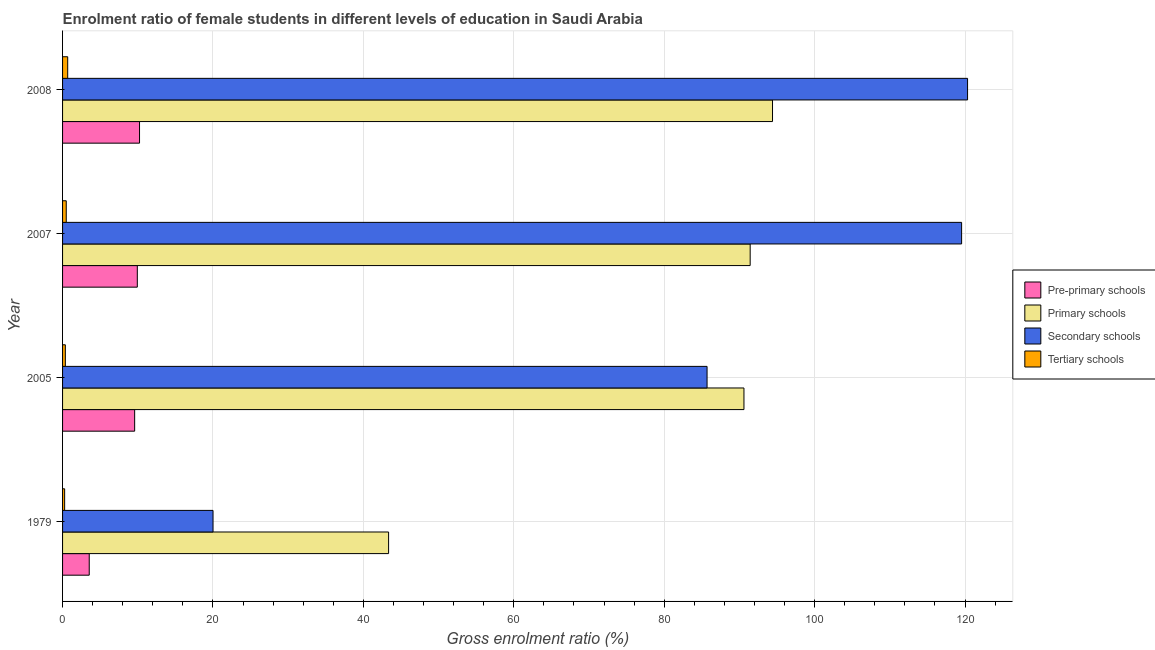Are the number of bars on each tick of the Y-axis equal?
Keep it short and to the point. Yes. How many bars are there on the 4th tick from the top?
Provide a short and direct response. 4. What is the label of the 4th group of bars from the top?
Provide a short and direct response. 1979. What is the gross enrolment ratio(male) in primary schools in 2005?
Make the answer very short. 90.6. Across all years, what is the maximum gross enrolment ratio(male) in secondary schools?
Provide a succinct answer. 120.33. Across all years, what is the minimum gross enrolment ratio(male) in tertiary schools?
Give a very brief answer. 0.28. In which year was the gross enrolment ratio(male) in pre-primary schools maximum?
Give a very brief answer. 2008. In which year was the gross enrolment ratio(male) in secondary schools minimum?
Your answer should be very brief. 1979. What is the total gross enrolment ratio(male) in pre-primary schools in the graph?
Provide a short and direct response. 33.31. What is the difference between the gross enrolment ratio(male) in secondary schools in 2005 and that in 2008?
Provide a short and direct response. -34.64. What is the difference between the gross enrolment ratio(male) in tertiary schools in 2005 and the gross enrolment ratio(male) in pre-primary schools in 2008?
Your answer should be compact. -9.86. What is the average gross enrolment ratio(male) in secondary schools per year?
Your answer should be compact. 86.39. In the year 2005, what is the difference between the gross enrolment ratio(male) in pre-primary schools and gross enrolment ratio(male) in secondary schools?
Offer a terse response. -76.11. What is the ratio of the gross enrolment ratio(male) in primary schools in 1979 to that in 2008?
Provide a short and direct response. 0.46. What is the difference between the highest and the second highest gross enrolment ratio(male) in tertiary schools?
Provide a short and direct response. 0.19. What is the difference between the highest and the lowest gross enrolment ratio(male) in pre-primary schools?
Make the answer very short. 6.69. In how many years, is the gross enrolment ratio(male) in primary schools greater than the average gross enrolment ratio(male) in primary schools taken over all years?
Make the answer very short. 3. What does the 3rd bar from the top in 1979 represents?
Your answer should be very brief. Primary schools. What does the 4th bar from the bottom in 2005 represents?
Your answer should be compact. Tertiary schools. How many bars are there?
Provide a short and direct response. 16. Are all the bars in the graph horizontal?
Provide a succinct answer. Yes. How many years are there in the graph?
Ensure brevity in your answer.  4. What is the difference between two consecutive major ticks on the X-axis?
Offer a very short reply. 20. Are the values on the major ticks of X-axis written in scientific E-notation?
Make the answer very short. No. Does the graph contain any zero values?
Your answer should be compact. No. How many legend labels are there?
Give a very brief answer. 4. How are the legend labels stacked?
Ensure brevity in your answer.  Vertical. What is the title of the graph?
Offer a terse response. Enrolment ratio of female students in different levels of education in Saudi Arabia. What is the label or title of the X-axis?
Make the answer very short. Gross enrolment ratio (%). What is the label or title of the Y-axis?
Provide a succinct answer. Year. What is the Gross enrolment ratio (%) in Pre-primary schools in 1979?
Provide a short and direct response. 3.55. What is the Gross enrolment ratio (%) of Primary schools in 1979?
Keep it short and to the point. 43.35. What is the Gross enrolment ratio (%) in Secondary schools in 1979?
Offer a terse response. 20.01. What is the Gross enrolment ratio (%) in Tertiary schools in 1979?
Your answer should be compact. 0.28. What is the Gross enrolment ratio (%) of Pre-primary schools in 2005?
Ensure brevity in your answer.  9.59. What is the Gross enrolment ratio (%) of Primary schools in 2005?
Make the answer very short. 90.6. What is the Gross enrolment ratio (%) in Secondary schools in 2005?
Offer a terse response. 85.7. What is the Gross enrolment ratio (%) in Tertiary schools in 2005?
Ensure brevity in your answer.  0.37. What is the Gross enrolment ratio (%) of Pre-primary schools in 2007?
Ensure brevity in your answer.  9.94. What is the Gross enrolment ratio (%) in Primary schools in 2007?
Your answer should be very brief. 91.43. What is the Gross enrolment ratio (%) in Secondary schools in 2007?
Give a very brief answer. 119.54. What is the Gross enrolment ratio (%) of Tertiary schools in 2007?
Offer a very short reply. 0.49. What is the Gross enrolment ratio (%) in Pre-primary schools in 2008?
Your answer should be compact. 10.23. What is the Gross enrolment ratio (%) in Primary schools in 2008?
Give a very brief answer. 94.4. What is the Gross enrolment ratio (%) in Secondary schools in 2008?
Your response must be concise. 120.33. What is the Gross enrolment ratio (%) of Tertiary schools in 2008?
Your answer should be very brief. 0.68. Across all years, what is the maximum Gross enrolment ratio (%) in Pre-primary schools?
Your answer should be very brief. 10.23. Across all years, what is the maximum Gross enrolment ratio (%) of Primary schools?
Make the answer very short. 94.4. Across all years, what is the maximum Gross enrolment ratio (%) in Secondary schools?
Your response must be concise. 120.33. Across all years, what is the maximum Gross enrolment ratio (%) of Tertiary schools?
Offer a very short reply. 0.68. Across all years, what is the minimum Gross enrolment ratio (%) of Pre-primary schools?
Offer a terse response. 3.55. Across all years, what is the minimum Gross enrolment ratio (%) in Primary schools?
Your response must be concise. 43.35. Across all years, what is the minimum Gross enrolment ratio (%) in Secondary schools?
Offer a very short reply. 20.01. Across all years, what is the minimum Gross enrolment ratio (%) in Tertiary schools?
Offer a very short reply. 0.28. What is the total Gross enrolment ratio (%) of Pre-primary schools in the graph?
Make the answer very short. 33.31. What is the total Gross enrolment ratio (%) in Primary schools in the graph?
Give a very brief answer. 319.78. What is the total Gross enrolment ratio (%) of Secondary schools in the graph?
Ensure brevity in your answer.  345.57. What is the total Gross enrolment ratio (%) of Tertiary schools in the graph?
Your response must be concise. 1.82. What is the difference between the Gross enrolment ratio (%) in Pre-primary schools in 1979 and that in 2005?
Make the answer very short. -6.04. What is the difference between the Gross enrolment ratio (%) in Primary schools in 1979 and that in 2005?
Provide a short and direct response. -47.25. What is the difference between the Gross enrolment ratio (%) in Secondary schools in 1979 and that in 2005?
Your answer should be very brief. -65.69. What is the difference between the Gross enrolment ratio (%) of Tertiary schools in 1979 and that in 2005?
Keep it short and to the point. -0.09. What is the difference between the Gross enrolment ratio (%) in Pre-primary schools in 1979 and that in 2007?
Your response must be concise. -6.39. What is the difference between the Gross enrolment ratio (%) in Primary schools in 1979 and that in 2007?
Offer a terse response. -48.08. What is the difference between the Gross enrolment ratio (%) of Secondary schools in 1979 and that in 2007?
Provide a succinct answer. -99.53. What is the difference between the Gross enrolment ratio (%) in Tertiary schools in 1979 and that in 2007?
Make the answer very short. -0.21. What is the difference between the Gross enrolment ratio (%) of Pre-primary schools in 1979 and that in 2008?
Offer a very short reply. -6.69. What is the difference between the Gross enrolment ratio (%) of Primary schools in 1979 and that in 2008?
Offer a very short reply. -51.05. What is the difference between the Gross enrolment ratio (%) of Secondary schools in 1979 and that in 2008?
Provide a succinct answer. -100.33. What is the difference between the Gross enrolment ratio (%) in Tertiary schools in 1979 and that in 2008?
Make the answer very short. -0.41. What is the difference between the Gross enrolment ratio (%) of Pre-primary schools in 2005 and that in 2007?
Make the answer very short. -0.35. What is the difference between the Gross enrolment ratio (%) in Primary schools in 2005 and that in 2007?
Offer a terse response. -0.83. What is the difference between the Gross enrolment ratio (%) in Secondary schools in 2005 and that in 2007?
Give a very brief answer. -33.85. What is the difference between the Gross enrolment ratio (%) in Tertiary schools in 2005 and that in 2007?
Make the answer very short. -0.12. What is the difference between the Gross enrolment ratio (%) in Pre-primary schools in 2005 and that in 2008?
Your answer should be compact. -0.65. What is the difference between the Gross enrolment ratio (%) of Primary schools in 2005 and that in 2008?
Your answer should be very brief. -3.8. What is the difference between the Gross enrolment ratio (%) of Secondary schools in 2005 and that in 2008?
Offer a terse response. -34.64. What is the difference between the Gross enrolment ratio (%) in Tertiary schools in 2005 and that in 2008?
Give a very brief answer. -0.31. What is the difference between the Gross enrolment ratio (%) of Pre-primary schools in 2007 and that in 2008?
Your response must be concise. -0.29. What is the difference between the Gross enrolment ratio (%) in Primary schools in 2007 and that in 2008?
Offer a very short reply. -2.97. What is the difference between the Gross enrolment ratio (%) of Secondary schools in 2007 and that in 2008?
Your answer should be compact. -0.79. What is the difference between the Gross enrolment ratio (%) in Tertiary schools in 2007 and that in 2008?
Ensure brevity in your answer.  -0.19. What is the difference between the Gross enrolment ratio (%) in Pre-primary schools in 1979 and the Gross enrolment ratio (%) in Primary schools in 2005?
Provide a succinct answer. -87.05. What is the difference between the Gross enrolment ratio (%) in Pre-primary schools in 1979 and the Gross enrolment ratio (%) in Secondary schools in 2005?
Provide a succinct answer. -82.15. What is the difference between the Gross enrolment ratio (%) in Pre-primary schools in 1979 and the Gross enrolment ratio (%) in Tertiary schools in 2005?
Your response must be concise. 3.18. What is the difference between the Gross enrolment ratio (%) of Primary schools in 1979 and the Gross enrolment ratio (%) of Secondary schools in 2005?
Offer a terse response. -42.34. What is the difference between the Gross enrolment ratio (%) of Primary schools in 1979 and the Gross enrolment ratio (%) of Tertiary schools in 2005?
Your response must be concise. 42.98. What is the difference between the Gross enrolment ratio (%) of Secondary schools in 1979 and the Gross enrolment ratio (%) of Tertiary schools in 2005?
Offer a very short reply. 19.64. What is the difference between the Gross enrolment ratio (%) of Pre-primary schools in 1979 and the Gross enrolment ratio (%) of Primary schools in 2007?
Your response must be concise. -87.88. What is the difference between the Gross enrolment ratio (%) of Pre-primary schools in 1979 and the Gross enrolment ratio (%) of Secondary schools in 2007?
Keep it short and to the point. -115.99. What is the difference between the Gross enrolment ratio (%) in Pre-primary schools in 1979 and the Gross enrolment ratio (%) in Tertiary schools in 2007?
Give a very brief answer. 3.06. What is the difference between the Gross enrolment ratio (%) of Primary schools in 1979 and the Gross enrolment ratio (%) of Secondary schools in 2007?
Your answer should be compact. -76.19. What is the difference between the Gross enrolment ratio (%) in Primary schools in 1979 and the Gross enrolment ratio (%) in Tertiary schools in 2007?
Your answer should be compact. 42.86. What is the difference between the Gross enrolment ratio (%) of Secondary schools in 1979 and the Gross enrolment ratio (%) of Tertiary schools in 2007?
Provide a succinct answer. 19.52. What is the difference between the Gross enrolment ratio (%) in Pre-primary schools in 1979 and the Gross enrolment ratio (%) in Primary schools in 2008?
Ensure brevity in your answer.  -90.85. What is the difference between the Gross enrolment ratio (%) of Pre-primary schools in 1979 and the Gross enrolment ratio (%) of Secondary schools in 2008?
Ensure brevity in your answer.  -116.78. What is the difference between the Gross enrolment ratio (%) of Pre-primary schools in 1979 and the Gross enrolment ratio (%) of Tertiary schools in 2008?
Give a very brief answer. 2.86. What is the difference between the Gross enrolment ratio (%) in Primary schools in 1979 and the Gross enrolment ratio (%) in Secondary schools in 2008?
Give a very brief answer. -76.98. What is the difference between the Gross enrolment ratio (%) of Primary schools in 1979 and the Gross enrolment ratio (%) of Tertiary schools in 2008?
Your answer should be compact. 42.67. What is the difference between the Gross enrolment ratio (%) of Secondary schools in 1979 and the Gross enrolment ratio (%) of Tertiary schools in 2008?
Give a very brief answer. 19.32. What is the difference between the Gross enrolment ratio (%) of Pre-primary schools in 2005 and the Gross enrolment ratio (%) of Primary schools in 2007?
Offer a very short reply. -81.84. What is the difference between the Gross enrolment ratio (%) of Pre-primary schools in 2005 and the Gross enrolment ratio (%) of Secondary schools in 2007?
Offer a very short reply. -109.95. What is the difference between the Gross enrolment ratio (%) of Pre-primary schools in 2005 and the Gross enrolment ratio (%) of Tertiary schools in 2007?
Your answer should be very brief. 9.1. What is the difference between the Gross enrolment ratio (%) of Primary schools in 2005 and the Gross enrolment ratio (%) of Secondary schools in 2007?
Your response must be concise. -28.94. What is the difference between the Gross enrolment ratio (%) in Primary schools in 2005 and the Gross enrolment ratio (%) in Tertiary schools in 2007?
Your answer should be compact. 90.11. What is the difference between the Gross enrolment ratio (%) of Secondary schools in 2005 and the Gross enrolment ratio (%) of Tertiary schools in 2007?
Keep it short and to the point. 85.21. What is the difference between the Gross enrolment ratio (%) in Pre-primary schools in 2005 and the Gross enrolment ratio (%) in Primary schools in 2008?
Your response must be concise. -84.81. What is the difference between the Gross enrolment ratio (%) in Pre-primary schools in 2005 and the Gross enrolment ratio (%) in Secondary schools in 2008?
Give a very brief answer. -110.75. What is the difference between the Gross enrolment ratio (%) of Pre-primary schools in 2005 and the Gross enrolment ratio (%) of Tertiary schools in 2008?
Make the answer very short. 8.9. What is the difference between the Gross enrolment ratio (%) of Primary schools in 2005 and the Gross enrolment ratio (%) of Secondary schools in 2008?
Keep it short and to the point. -29.73. What is the difference between the Gross enrolment ratio (%) of Primary schools in 2005 and the Gross enrolment ratio (%) of Tertiary schools in 2008?
Offer a terse response. 89.92. What is the difference between the Gross enrolment ratio (%) in Secondary schools in 2005 and the Gross enrolment ratio (%) in Tertiary schools in 2008?
Offer a terse response. 85.01. What is the difference between the Gross enrolment ratio (%) in Pre-primary schools in 2007 and the Gross enrolment ratio (%) in Primary schools in 2008?
Your response must be concise. -84.46. What is the difference between the Gross enrolment ratio (%) of Pre-primary schools in 2007 and the Gross enrolment ratio (%) of Secondary schools in 2008?
Offer a very short reply. -110.39. What is the difference between the Gross enrolment ratio (%) of Pre-primary schools in 2007 and the Gross enrolment ratio (%) of Tertiary schools in 2008?
Ensure brevity in your answer.  9.25. What is the difference between the Gross enrolment ratio (%) of Primary schools in 2007 and the Gross enrolment ratio (%) of Secondary schools in 2008?
Offer a terse response. -28.9. What is the difference between the Gross enrolment ratio (%) of Primary schools in 2007 and the Gross enrolment ratio (%) of Tertiary schools in 2008?
Offer a very short reply. 90.74. What is the difference between the Gross enrolment ratio (%) in Secondary schools in 2007 and the Gross enrolment ratio (%) in Tertiary schools in 2008?
Your response must be concise. 118.86. What is the average Gross enrolment ratio (%) in Pre-primary schools per year?
Keep it short and to the point. 8.33. What is the average Gross enrolment ratio (%) of Primary schools per year?
Offer a terse response. 79.94. What is the average Gross enrolment ratio (%) in Secondary schools per year?
Offer a very short reply. 86.39. What is the average Gross enrolment ratio (%) in Tertiary schools per year?
Keep it short and to the point. 0.46. In the year 1979, what is the difference between the Gross enrolment ratio (%) in Pre-primary schools and Gross enrolment ratio (%) in Primary schools?
Ensure brevity in your answer.  -39.8. In the year 1979, what is the difference between the Gross enrolment ratio (%) in Pre-primary schools and Gross enrolment ratio (%) in Secondary schools?
Provide a short and direct response. -16.46. In the year 1979, what is the difference between the Gross enrolment ratio (%) in Pre-primary schools and Gross enrolment ratio (%) in Tertiary schools?
Give a very brief answer. 3.27. In the year 1979, what is the difference between the Gross enrolment ratio (%) in Primary schools and Gross enrolment ratio (%) in Secondary schools?
Make the answer very short. 23.34. In the year 1979, what is the difference between the Gross enrolment ratio (%) of Primary schools and Gross enrolment ratio (%) of Tertiary schools?
Your answer should be very brief. 43.07. In the year 1979, what is the difference between the Gross enrolment ratio (%) of Secondary schools and Gross enrolment ratio (%) of Tertiary schools?
Ensure brevity in your answer.  19.73. In the year 2005, what is the difference between the Gross enrolment ratio (%) in Pre-primary schools and Gross enrolment ratio (%) in Primary schools?
Give a very brief answer. -81.01. In the year 2005, what is the difference between the Gross enrolment ratio (%) in Pre-primary schools and Gross enrolment ratio (%) in Secondary schools?
Keep it short and to the point. -76.11. In the year 2005, what is the difference between the Gross enrolment ratio (%) in Pre-primary schools and Gross enrolment ratio (%) in Tertiary schools?
Provide a succinct answer. 9.22. In the year 2005, what is the difference between the Gross enrolment ratio (%) in Primary schools and Gross enrolment ratio (%) in Secondary schools?
Provide a succinct answer. 4.91. In the year 2005, what is the difference between the Gross enrolment ratio (%) in Primary schools and Gross enrolment ratio (%) in Tertiary schools?
Offer a very short reply. 90.23. In the year 2005, what is the difference between the Gross enrolment ratio (%) in Secondary schools and Gross enrolment ratio (%) in Tertiary schools?
Provide a succinct answer. 85.33. In the year 2007, what is the difference between the Gross enrolment ratio (%) in Pre-primary schools and Gross enrolment ratio (%) in Primary schools?
Your response must be concise. -81.49. In the year 2007, what is the difference between the Gross enrolment ratio (%) in Pre-primary schools and Gross enrolment ratio (%) in Secondary schools?
Make the answer very short. -109.6. In the year 2007, what is the difference between the Gross enrolment ratio (%) of Pre-primary schools and Gross enrolment ratio (%) of Tertiary schools?
Offer a very short reply. 9.45. In the year 2007, what is the difference between the Gross enrolment ratio (%) in Primary schools and Gross enrolment ratio (%) in Secondary schools?
Your answer should be compact. -28.11. In the year 2007, what is the difference between the Gross enrolment ratio (%) of Primary schools and Gross enrolment ratio (%) of Tertiary schools?
Make the answer very short. 90.94. In the year 2007, what is the difference between the Gross enrolment ratio (%) in Secondary schools and Gross enrolment ratio (%) in Tertiary schools?
Provide a succinct answer. 119.05. In the year 2008, what is the difference between the Gross enrolment ratio (%) of Pre-primary schools and Gross enrolment ratio (%) of Primary schools?
Offer a terse response. -84.16. In the year 2008, what is the difference between the Gross enrolment ratio (%) in Pre-primary schools and Gross enrolment ratio (%) in Secondary schools?
Give a very brief answer. -110.1. In the year 2008, what is the difference between the Gross enrolment ratio (%) of Pre-primary schools and Gross enrolment ratio (%) of Tertiary schools?
Your answer should be very brief. 9.55. In the year 2008, what is the difference between the Gross enrolment ratio (%) of Primary schools and Gross enrolment ratio (%) of Secondary schools?
Your answer should be compact. -25.93. In the year 2008, what is the difference between the Gross enrolment ratio (%) in Primary schools and Gross enrolment ratio (%) in Tertiary schools?
Offer a terse response. 93.71. In the year 2008, what is the difference between the Gross enrolment ratio (%) of Secondary schools and Gross enrolment ratio (%) of Tertiary schools?
Your answer should be very brief. 119.65. What is the ratio of the Gross enrolment ratio (%) in Pre-primary schools in 1979 to that in 2005?
Make the answer very short. 0.37. What is the ratio of the Gross enrolment ratio (%) of Primary schools in 1979 to that in 2005?
Offer a terse response. 0.48. What is the ratio of the Gross enrolment ratio (%) in Secondary schools in 1979 to that in 2005?
Offer a terse response. 0.23. What is the ratio of the Gross enrolment ratio (%) in Tertiary schools in 1979 to that in 2005?
Offer a very short reply. 0.75. What is the ratio of the Gross enrolment ratio (%) of Pre-primary schools in 1979 to that in 2007?
Give a very brief answer. 0.36. What is the ratio of the Gross enrolment ratio (%) in Primary schools in 1979 to that in 2007?
Give a very brief answer. 0.47. What is the ratio of the Gross enrolment ratio (%) in Secondary schools in 1979 to that in 2007?
Your response must be concise. 0.17. What is the ratio of the Gross enrolment ratio (%) of Tertiary schools in 1979 to that in 2007?
Offer a very short reply. 0.56. What is the ratio of the Gross enrolment ratio (%) of Pre-primary schools in 1979 to that in 2008?
Provide a short and direct response. 0.35. What is the ratio of the Gross enrolment ratio (%) of Primary schools in 1979 to that in 2008?
Give a very brief answer. 0.46. What is the ratio of the Gross enrolment ratio (%) in Secondary schools in 1979 to that in 2008?
Make the answer very short. 0.17. What is the ratio of the Gross enrolment ratio (%) in Tertiary schools in 1979 to that in 2008?
Ensure brevity in your answer.  0.4. What is the ratio of the Gross enrolment ratio (%) in Pre-primary schools in 2005 to that in 2007?
Provide a short and direct response. 0.96. What is the ratio of the Gross enrolment ratio (%) in Primary schools in 2005 to that in 2007?
Ensure brevity in your answer.  0.99. What is the ratio of the Gross enrolment ratio (%) in Secondary schools in 2005 to that in 2007?
Offer a terse response. 0.72. What is the ratio of the Gross enrolment ratio (%) of Tertiary schools in 2005 to that in 2007?
Your answer should be compact. 0.76. What is the ratio of the Gross enrolment ratio (%) in Pre-primary schools in 2005 to that in 2008?
Your answer should be compact. 0.94. What is the ratio of the Gross enrolment ratio (%) in Primary schools in 2005 to that in 2008?
Your answer should be very brief. 0.96. What is the ratio of the Gross enrolment ratio (%) in Secondary schools in 2005 to that in 2008?
Offer a terse response. 0.71. What is the ratio of the Gross enrolment ratio (%) in Tertiary schools in 2005 to that in 2008?
Your answer should be very brief. 0.54. What is the ratio of the Gross enrolment ratio (%) of Pre-primary schools in 2007 to that in 2008?
Offer a very short reply. 0.97. What is the ratio of the Gross enrolment ratio (%) of Primary schools in 2007 to that in 2008?
Offer a terse response. 0.97. What is the ratio of the Gross enrolment ratio (%) of Secondary schools in 2007 to that in 2008?
Make the answer very short. 0.99. What is the ratio of the Gross enrolment ratio (%) in Tertiary schools in 2007 to that in 2008?
Your answer should be compact. 0.72. What is the difference between the highest and the second highest Gross enrolment ratio (%) of Pre-primary schools?
Make the answer very short. 0.29. What is the difference between the highest and the second highest Gross enrolment ratio (%) in Primary schools?
Your answer should be very brief. 2.97. What is the difference between the highest and the second highest Gross enrolment ratio (%) of Secondary schools?
Make the answer very short. 0.79. What is the difference between the highest and the second highest Gross enrolment ratio (%) of Tertiary schools?
Offer a very short reply. 0.19. What is the difference between the highest and the lowest Gross enrolment ratio (%) in Pre-primary schools?
Provide a succinct answer. 6.69. What is the difference between the highest and the lowest Gross enrolment ratio (%) in Primary schools?
Offer a very short reply. 51.05. What is the difference between the highest and the lowest Gross enrolment ratio (%) of Secondary schools?
Your response must be concise. 100.33. What is the difference between the highest and the lowest Gross enrolment ratio (%) in Tertiary schools?
Provide a short and direct response. 0.41. 